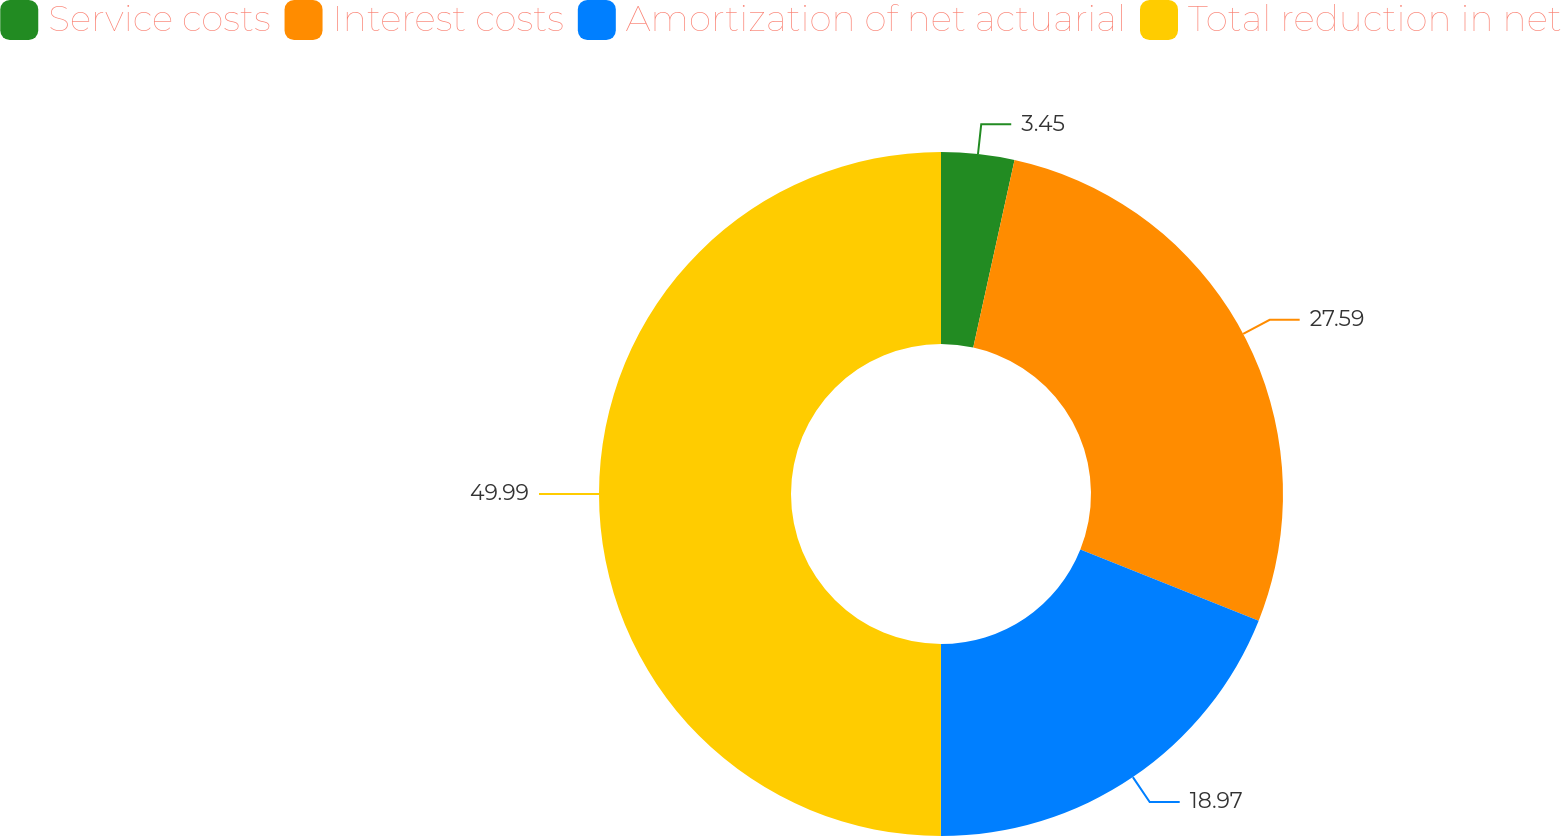<chart> <loc_0><loc_0><loc_500><loc_500><pie_chart><fcel>Service costs<fcel>Interest costs<fcel>Amortization of net actuarial<fcel>Total reduction in net<nl><fcel>3.45%<fcel>27.59%<fcel>18.97%<fcel>50.0%<nl></chart> 